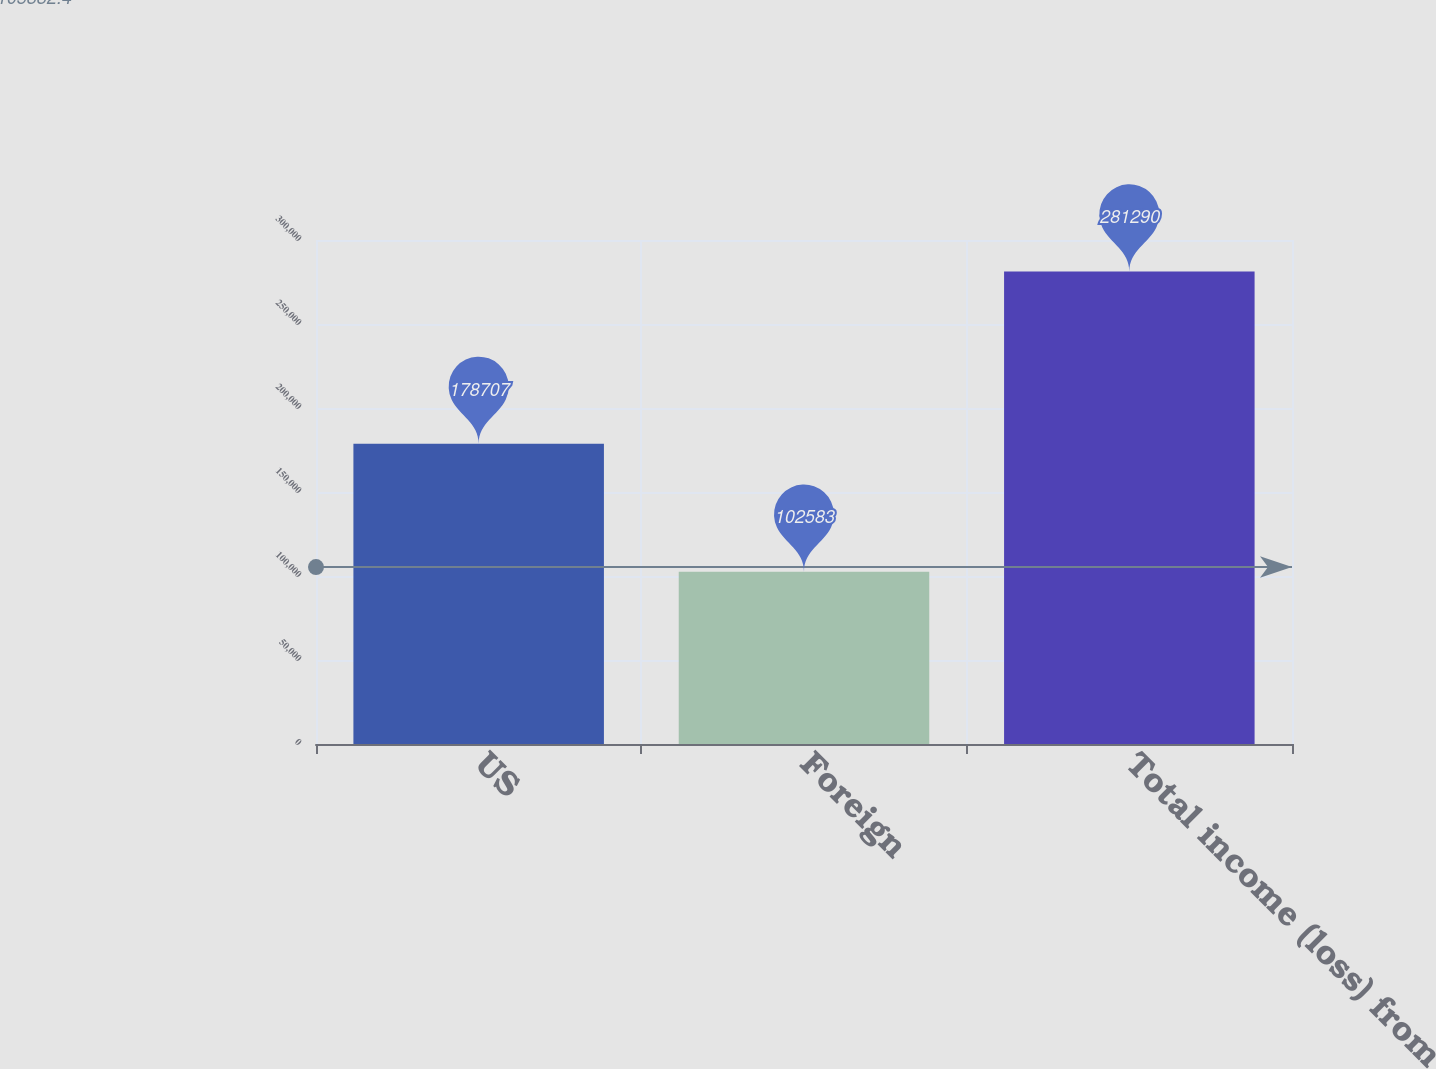<chart> <loc_0><loc_0><loc_500><loc_500><bar_chart><fcel>US<fcel>Foreign<fcel>Total income (loss) from<nl><fcel>178707<fcel>102583<fcel>281290<nl></chart> 